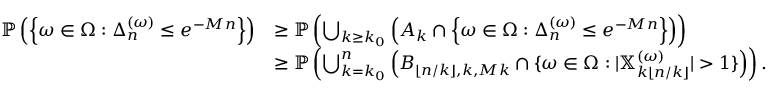Convert formula to latex. <formula><loc_0><loc_0><loc_500><loc_500>\begin{array} { r l } { \mathbb { P } \left ( \left \{ \omega \in \Omega \colon \Delta _ { n } ^ { ( \omega ) } \leq e ^ { - M n } \right \} \right ) } & { \geq \mathbb { P } \left ( \bigcup _ { k \geq k _ { 0 } } \left ( A _ { k } \cap \left \{ \omega \in \Omega \colon \Delta _ { n } ^ { ( \omega ) } \leq e ^ { - M n } \right \} \right ) \right ) } \\ & { \geq \mathbb { P } \left ( \bigcup _ { k = k _ { 0 } } ^ { n } \left ( B _ { \lfloor n / k \rfloor , k , M k } \cap \{ \omega \in \Omega \colon | \mathbb { X } _ { k \lfloor n / k \rfloor } ^ { ( \omega ) } | > 1 \} \right ) \right ) . } \end{array}</formula> 